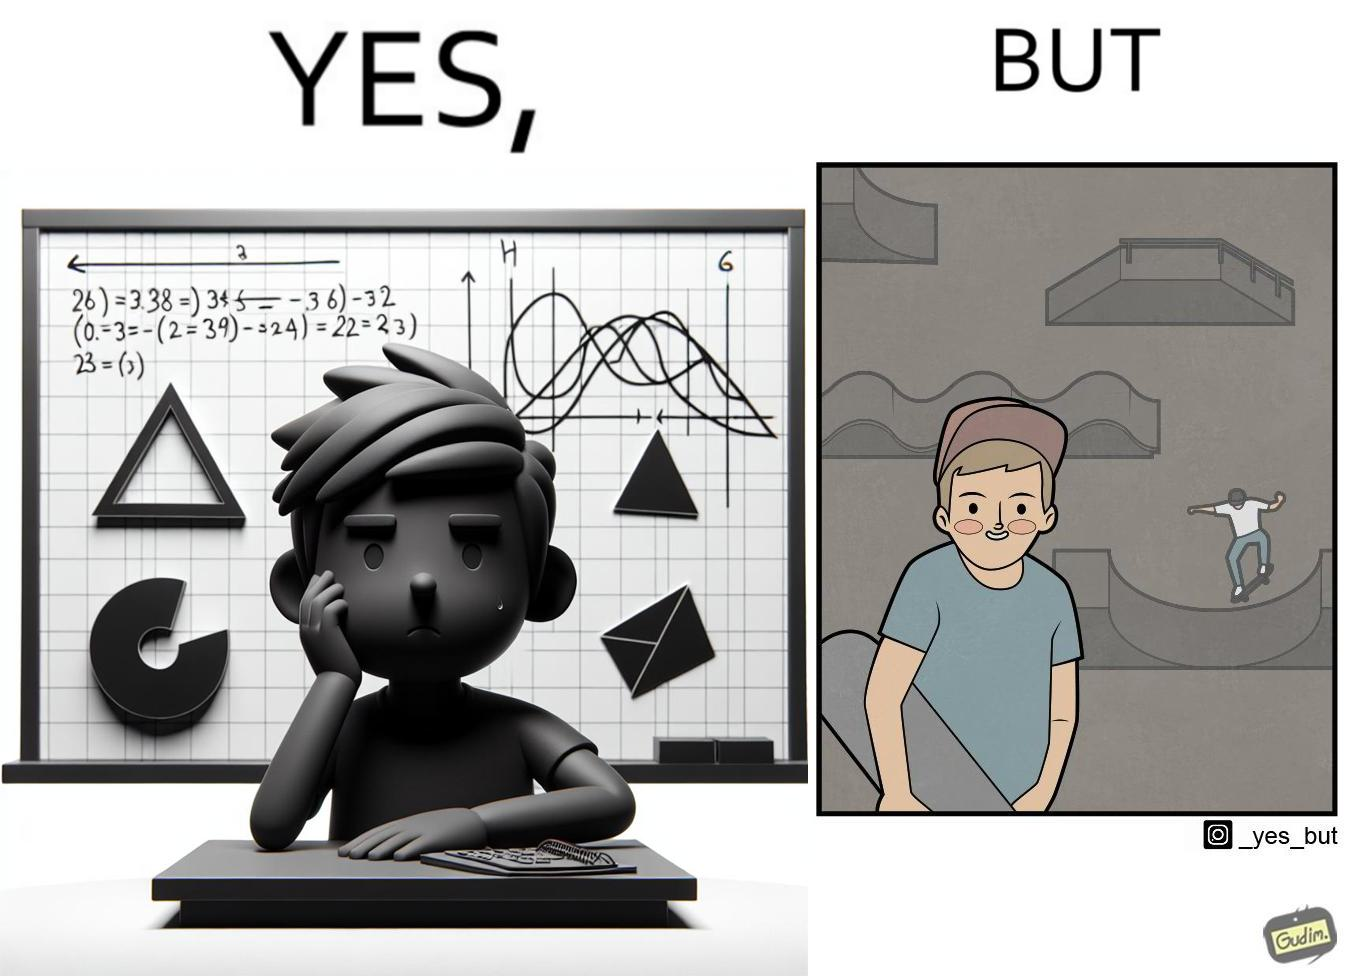Describe the contrast between the left and right parts of this image. In the left part of the image: The image shows a boy annoyed with studying maths. Behind him is a board with lots of shapes like  semi-circle and trapezoid drawn along with mathematical formulas like areas of circle. There is a graph of sinusodial curve also drawn on the board. In the right part of the image: The image shows a boy wearing a cap with a skateboard in his hands. He is happy. In his background there is a skateboard park. In the background there is a person skateboarding on a semi cirular bowl. We also see bowls of other shapes like trapezoid and sine wave. 